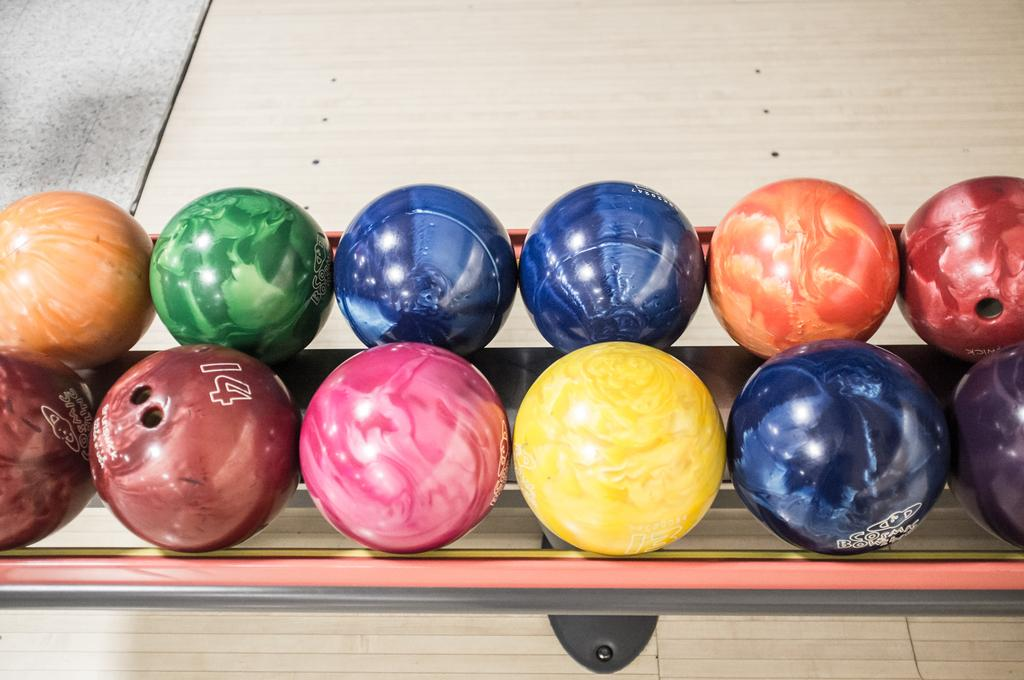What objects are present in the image? There are balls in the image. Can you describe the appearance of the balls? The balls have different colors. Where are the balls located? The balls are on a table. What type of structure is the spy hiding behind in the image? There is no spy or structure present in the image; it only features balls on a table. 